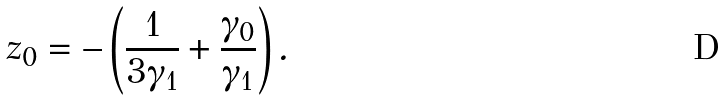<formula> <loc_0><loc_0><loc_500><loc_500>z _ { 0 } = - \left ( \frac { 1 } { 3 \gamma _ { 1 } } + \frac { \gamma _ { 0 } } { \gamma _ { 1 } } \right ) .</formula> 